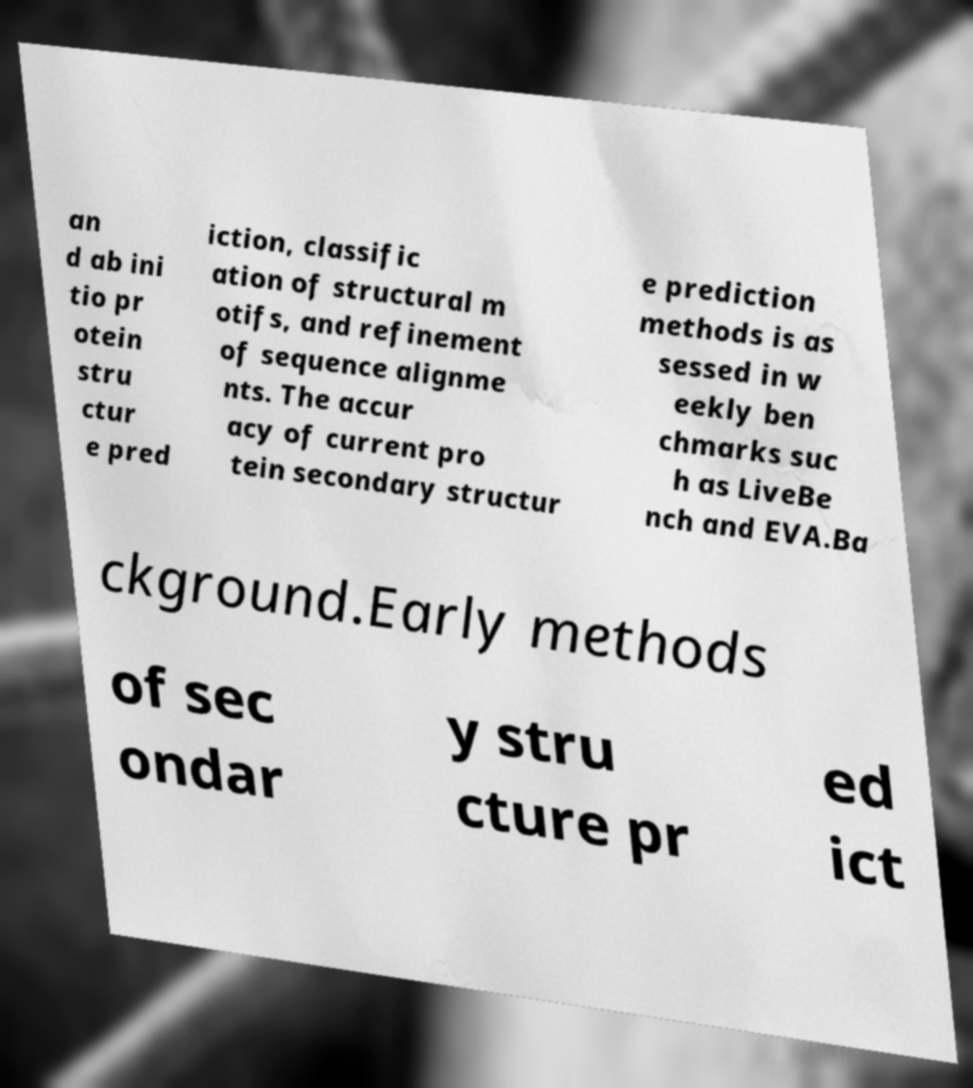Can you read and provide the text displayed in the image?This photo seems to have some interesting text. Can you extract and type it out for me? an d ab ini tio pr otein stru ctur e pred iction, classific ation of structural m otifs, and refinement of sequence alignme nts. The accur acy of current pro tein secondary structur e prediction methods is as sessed in w eekly ben chmarks suc h as LiveBe nch and EVA.Ba ckground.Early methods of sec ondar y stru cture pr ed ict 